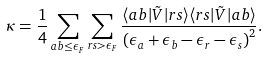Convert formula to latex. <formula><loc_0><loc_0><loc_500><loc_500>\kappa = \frac { 1 } { 4 } \sum _ { a b \leq \epsilon _ { F } } \sum _ { r s > \epsilon _ { F } } \frac { \langle a b | \tilde { V } | r s \rangle \langle r s | \tilde { V } | a b \rangle } { \left ( \epsilon _ { a } + \epsilon _ { b } - \epsilon _ { r } - \epsilon _ { s } \right ) ^ { 2 } } .</formula> 